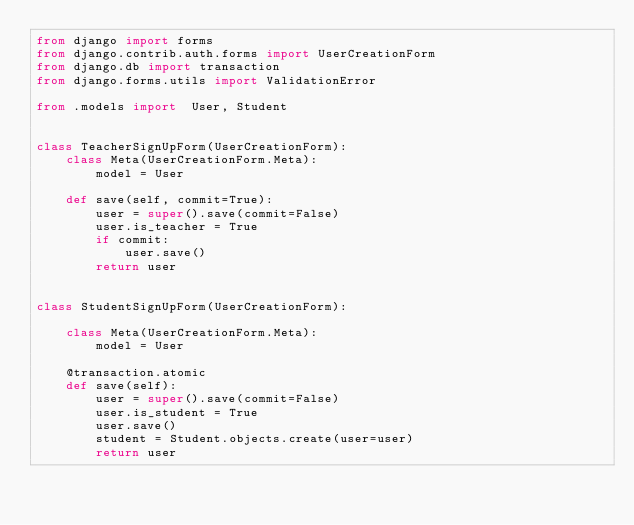Convert code to text. <code><loc_0><loc_0><loc_500><loc_500><_Python_>from django import forms
from django.contrib.auth.forms import UserCreationForm
from django.db import transaction
from django.forms.utils import ValidationError

from .models import  User, Student


class TeacherSignUpForm(UserCreationForm):
    class Meta(UserCreationForm.Meta):
        model = User

    def save(self, commit=True):
        user = super().save(commit=False)
        user.is_teacher = True
        if commit:
            user.save()
        return user


class StudentSignUpForm(UserCreationForm):

    class Meta(UserCreationForm.Meta):
        model = User

    @transaction.atomic
    def save(self):
        user = super().save(commit=False)
        user.is_student = True
        user.save()
        student = Student.objects.create(user=user)
        return user
</code> 